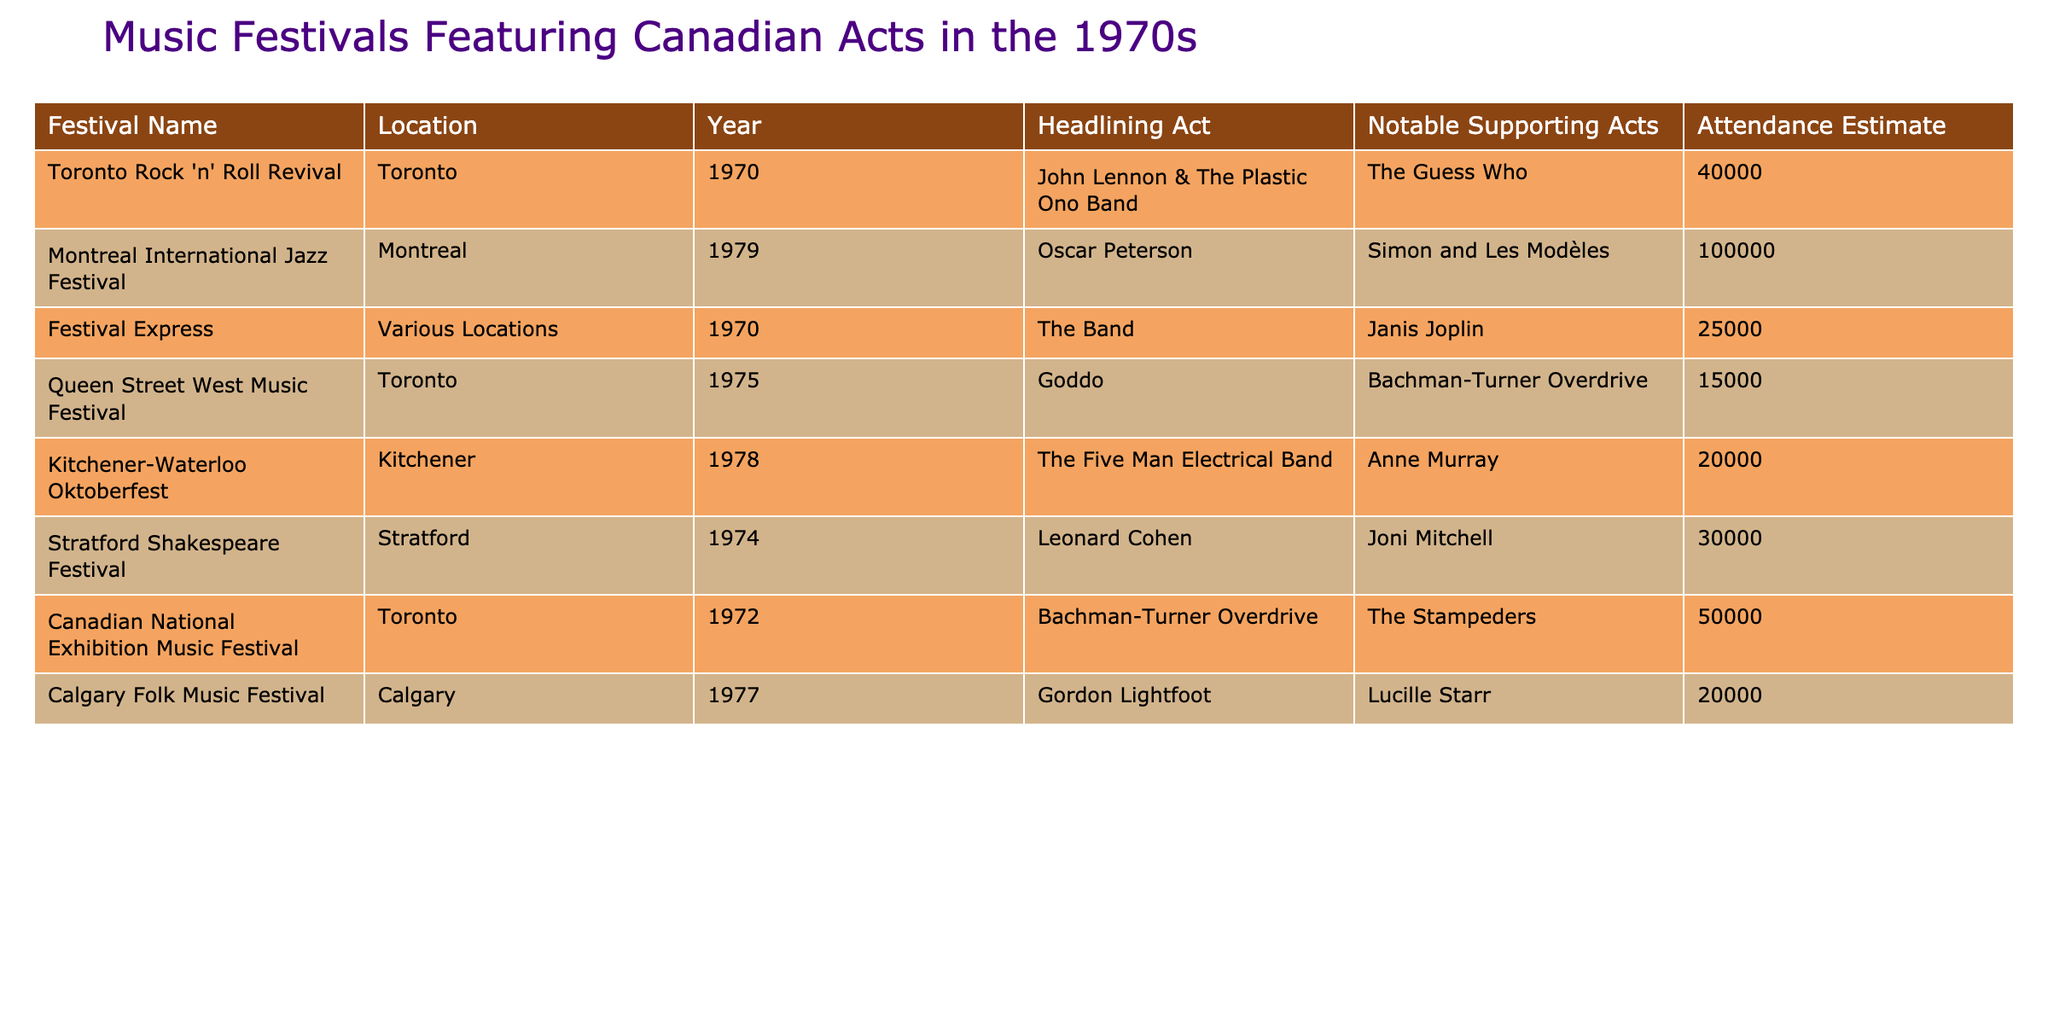What was the headlining act at the Toronto Rock 'n' Roll Revival festival? The table shows that the headlining act for the Toronto Rock 'n' Roll Revival festival in 1970 was John Lennon & The Plastic Ono Band. This can be seen directly in the corresponding row for this festival.
Answer: John Lennon & The Plastic Ono Band Which festival had the highest estimated attendance? By examining the attendance estimates in the table, the Montreal International Jazz Festival in 1979 had the highest estimated attendance of 100000. This can be determined by comparing all attendance figures across the festivals listed.
Answer: 100000 How many festivals featured Gordon Lightfoot? Checking the table, Gordon Lightfoot is mentioned as the headlining act only at the Calgary Folk Music Festival in 1977. Thus, he only appeared in one festival listed.
Answer: 1 What's the combined attendance of the festivals held in Toronto? The festivals held in Toronto are the Toronto Rock 'n' Roll Revival (40000), Canadian National Exhibition Music Festival (50000), and Queen Street West Music Festival (15000). Adding these attendance numbers results in 40000 + 50000 + 15000 = 105000. So, the combined attendance is 105000.
Answer: 105000 Did Leonard Cohen perform at more than one music festival during the 1970s according to the table? The table indicates that Leonard Cohen was the headlining act at the Stratford Shakespeare Festival in 1974. There is no other festival listed where he performed, thereby confirming he only appeared at one festival. Therefore, the answer is no.
Answer: No What year did the Kitchener-Waterloo Oktoberfest take place? Referring to the table, the Kitchener-Waterloo Oktoberfest is indicated to have taken place in 1978. This information is clearly mentioned in the row for this festival.
Answer: 1978 Which notable supporting act performed at the Festival Express? According to the table for the Festival Express in 1970, Janis Joplin is listed as a notable supporting act. This can be easily seen in that specific row.
Answer: Janis Joplin What was the average attendance across all festivals listed? To find the average attendance, sum the attendance figures for all festivals: 40000 + 100000 + 25000 + 15000 + 20000 + 30000 + 50000 + 20000 = 240000. There are eight festivals, so the average is 240000 divided by 8, which equals 30000.
Answer: 30000 How many different locations hosted music festivals that featured Canadian acts in the 1970s? The table lists the following locations: Toronto, Montreal, Kitchener, Stratford, and Calgary. These correspond to five different locations where the festivals took place. Thus, the total is five.
Answer: 5 